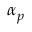Convert formula to latex. <formula><loc_0><loc_0><loc_500><loc_500>\alpha _ { p }</formula> 